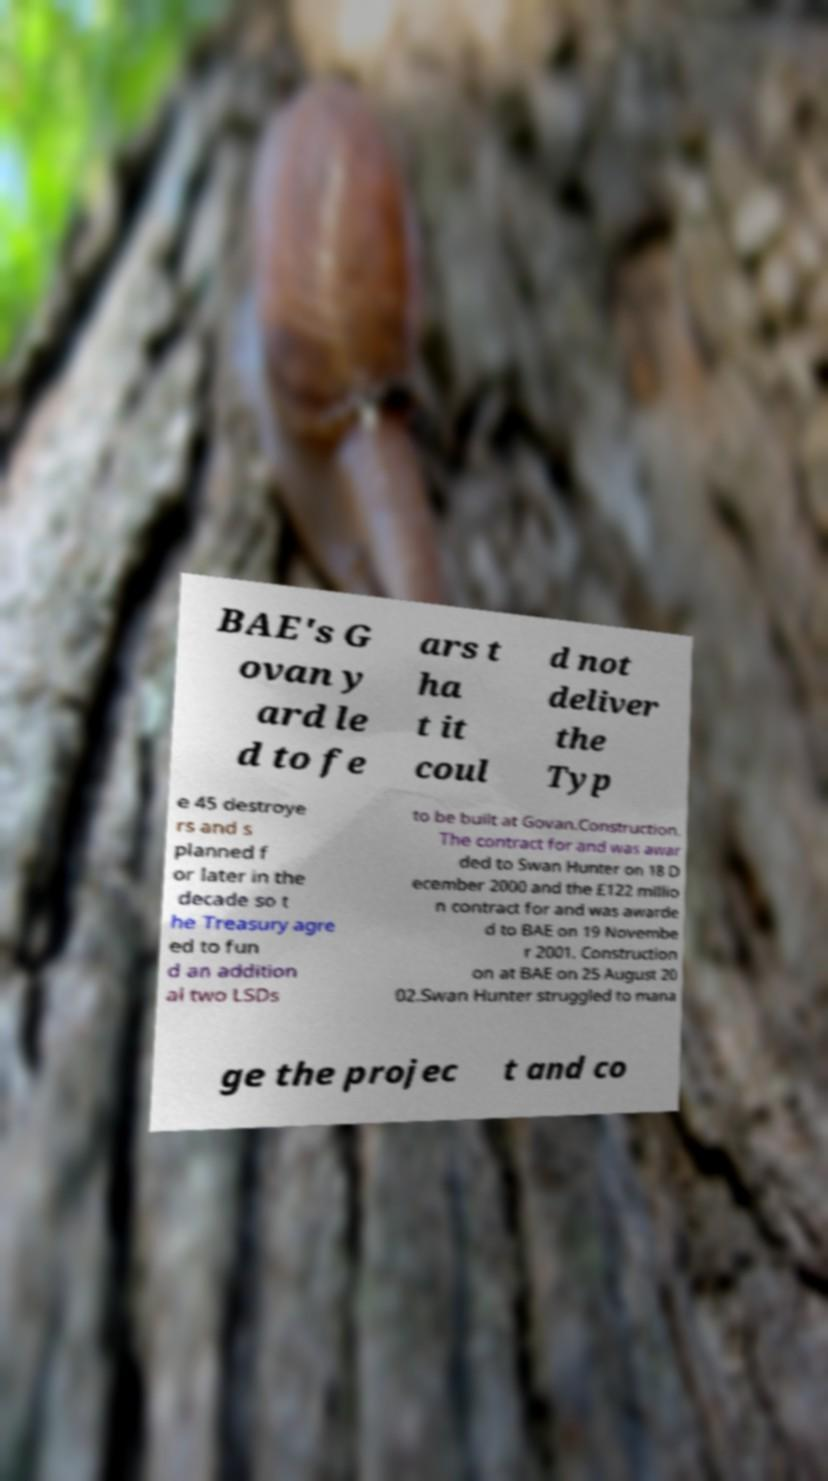Please identify and transcribe the text found in this image. BAE's G ovan y ard le d to fe ars t ha t it coul d not deliver the Typ e 45 destroye rs and s planned f or later in the decade so t he Treasury agre ed to fun d an addition al two LSDs to be built at Govan.Construction. The contract for and was awar ded to Swan Hunter on 18 D ecember 2000 and the £122 millio n contract for and was awarde d to BAE on 19 Novembe r 2001. Construction on at BAE on 25 August 20 02.Swan Hunter struggled to mana ge the projec t and co 